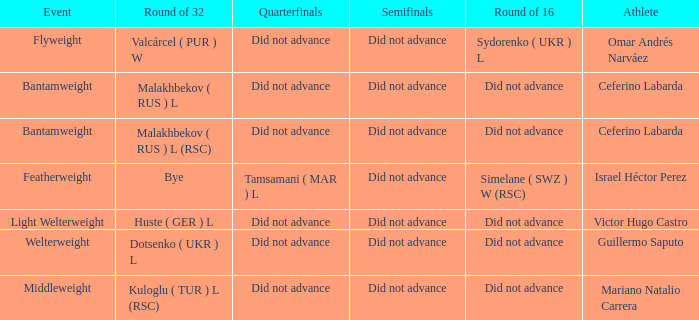Which athlete competed in the flyweight division? Omar Andrés Narváez. 